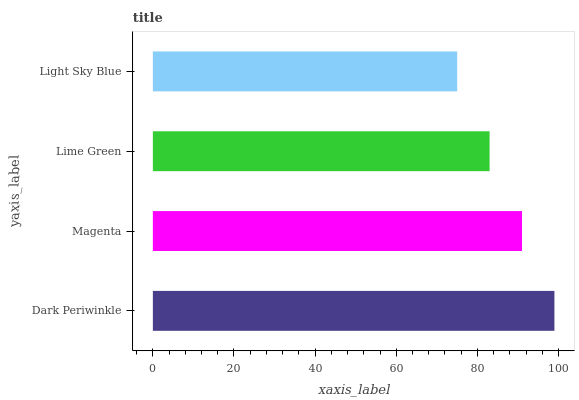Is Light Sky Blue the minimum?
Answer yes or no. Yes. Is Dark Periwinkle the maximum?
Answer yes or no. Yes. Is Magenta the minimum?
Answer yes or no. No. Is Magenta the maximum?
Answer yes or no. No. Is Dark Periwinkle greater than Magenta?
Answer yes or no. Yes. Is Magenta less than Dark Periwinkle?
Answer yes or no. Yes. Is Magenta greater than Dark Periwinkle?
Answer yes or no. No. Is Dark Periwinkle less than Magenta?
Answer yes or no. No. Is Magenta the high median?
Answer yes or no. Yes. Is Lime Green the low median?
Answer yes or no. Yes. Is Dark Periwinkle the high median?
Answer yes or no. No. Is Magenta the low median?
Answer yes or no. No. 